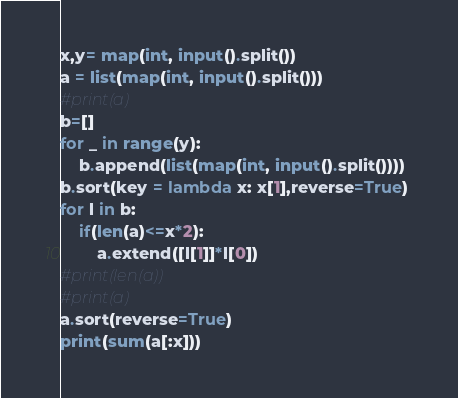Convert code to text. <code><loc_0><loc_0><loc_500><loc_500><_Python_>x,y= map(int, input().split())
a = list(map(int, input().split()))
#print(a)
b=[]
for _ in range(y):
    b.append(list(map(int, input().split())))
b.sort(key = lambda x: x[1],reverse=True) 
for l in b:
    if(len(a)<=x*2):
        a.extend([l[1]]*l[0])
#print(len(a))        
#print(a)
a.sort(reverse=True)
print(sum(a[:x]))
</code> 